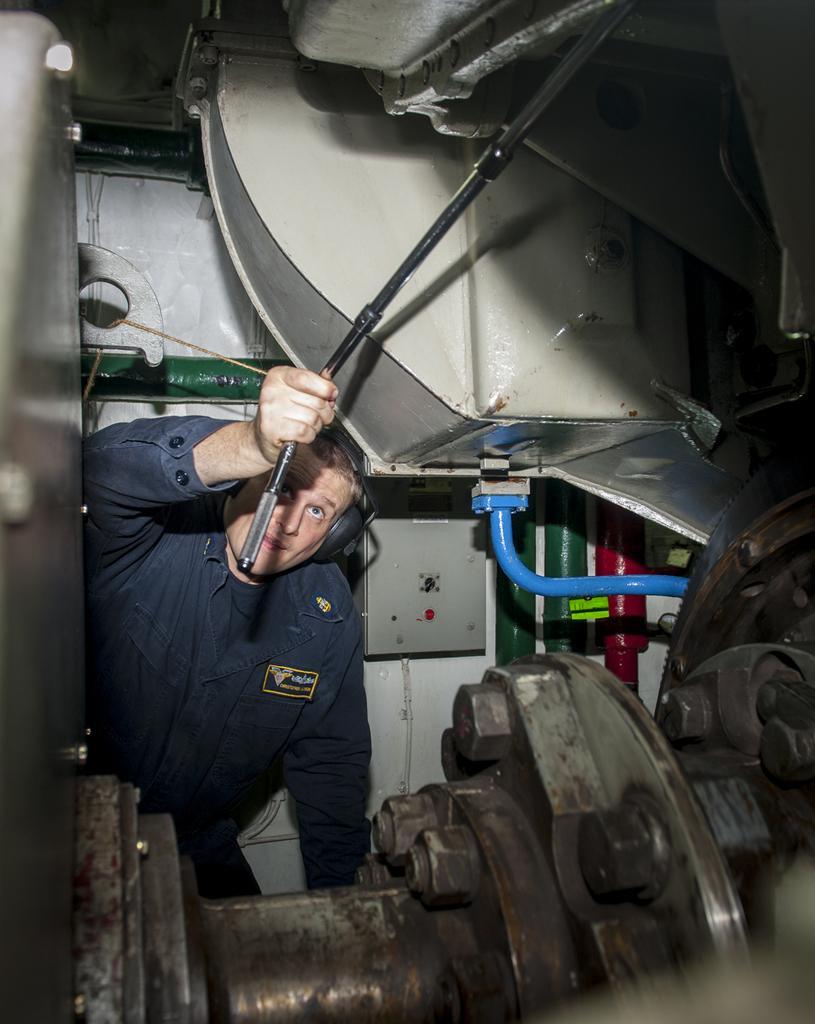Describe this image in one or two sentences. In this image we can see a person wearing blue color dress holding some iron stick in his hands and doing some work near the object. 